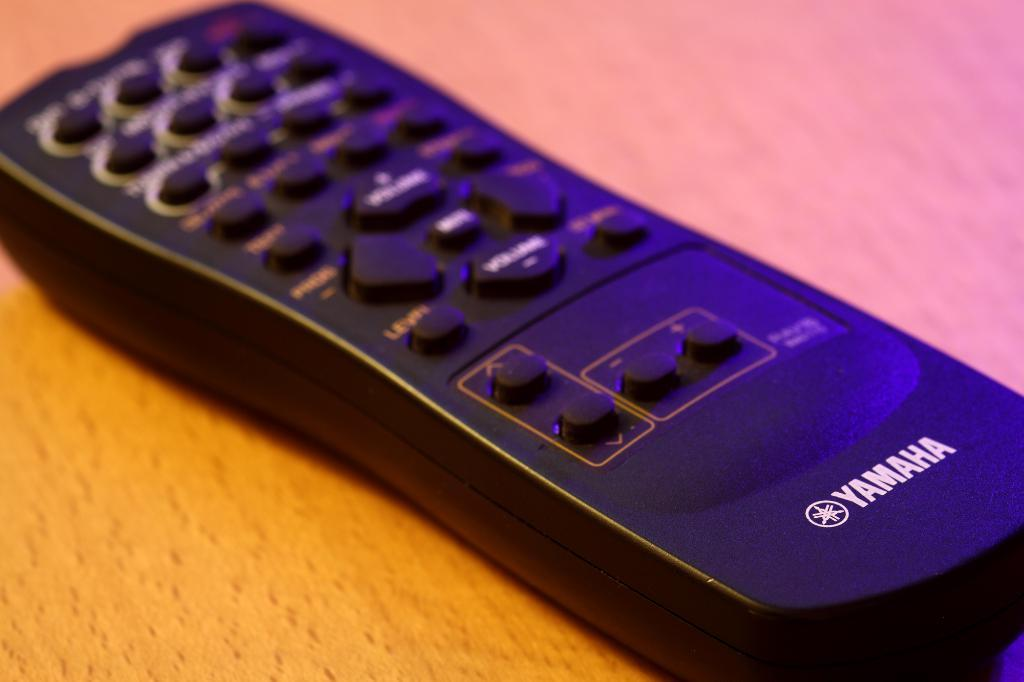<image>
Create a compact narrative representing the image presented. Television remote control from Yamaha on top of a wooden table. 